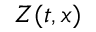<formula> <loc_0><loc_0><loc_500><loc_500>Z ( t , x )</formula> 